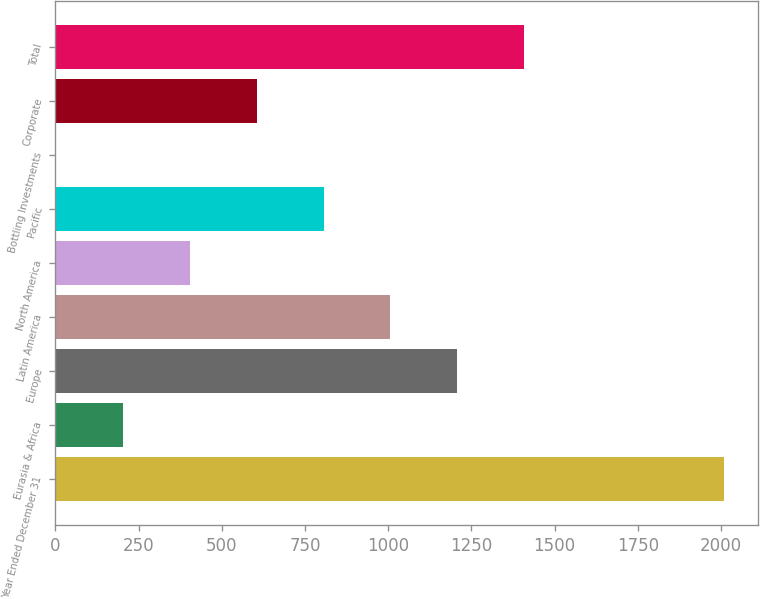Convert chart to OTSL. <chart><loc_0><loc_0><loc_500><loc_500><bar_chart><fcel>Year Ended December 31<fcel>Eurasia & Africa<fcel>Europe<fcel>Latin America<fcel>North America<fcel>Pacific<fcel>Bottling Investments<fcel>Corporate<fcel>Total<nl><fcel>2010<fcel>203.43<fcel>1207.08<fcel>1006.35<fcel>404.16<fcel>805.62<fcel>2.7<fcel>604.89<fcel>1407.81<nl></chart> 